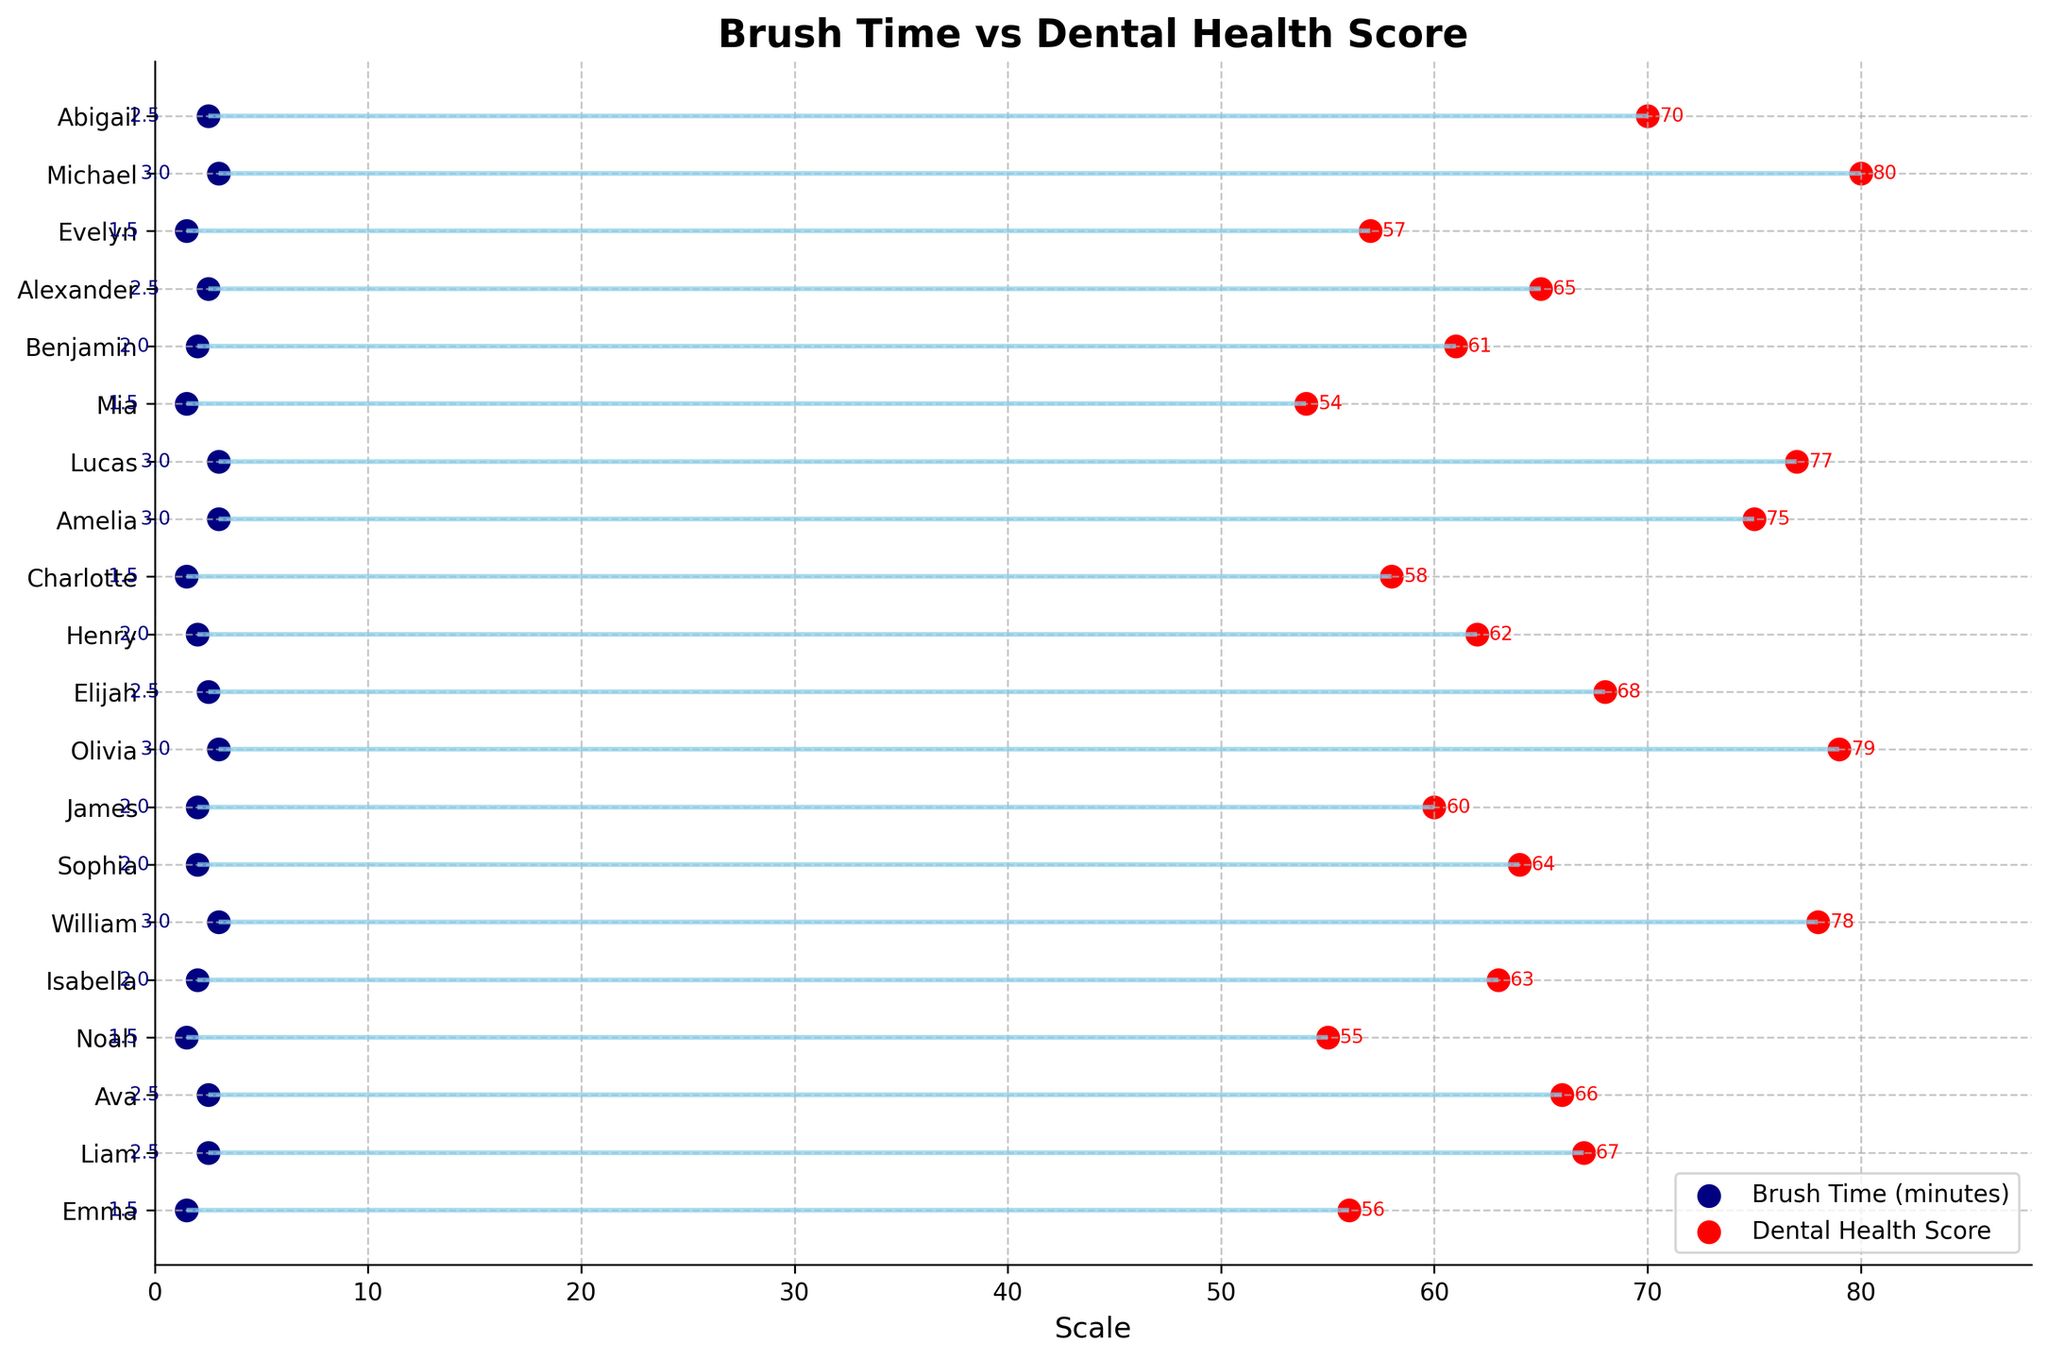How many kids' dental health scores are shown in the figure? The figure shows scores for each individual kid represented on the y-axis. Count the number of unique names on the y-axis.
Answer: 20 What is the average brush time of Charlotte and Lucas? Look at the points and annotations for Charlotte and Lucas on the brush time side (left side), then calculate the mean: (3+3)/2.
Answer: 3 Which kid has the highest dental health score? Look at the right-side points and annotations for dental health scores; find the highest value and its associated name.
Answer: Sophia Is there a kid who brushes 3 minutes but has a dental health score less than 60? Look at the brush time points on the left side to find those corresponding to 3 minutes and then check their dental health scores on the right side.
Answer: No What is the difference in dental health score between William and Amelia? Locate William and Amelia's dental health scores on the right side and subtract Amelia's score from William's score: 70 - 66.
Answer: 4 Do kids who brush for 3 minutes generally have higher dental health scores? Observe the positions of the brush time points at 3 minutes and compare them to their corresponding dental health scores on the right side; note where these scores fall in the range.
Answer: Yes Which kid has the smallest difference between brush time and dental health score? Calculate the absolute difference between the brush time and health score for each kid, then find the smallest one. E.g., Henry (2.5, 68) ->
Answer: Henry (0.5) Are there any kids who spent less than 2 minutes brushing but have a dental health score above 60? Check the left-side points for those less than 2 minutes and then verify if their corresponding right-side scores are above 60.
Answer: James What's the median dental health score? List all dental health scores from smallest to largest and find the middle value, or the average of the two middle values.
Answer: 63 Can you find a trend between brush time and dental health score in this plot? Look for general patterns in the positions of the brush time and dental health score points. Generally, as brush times go up, dental health scores also increase.
Answer: Yes 